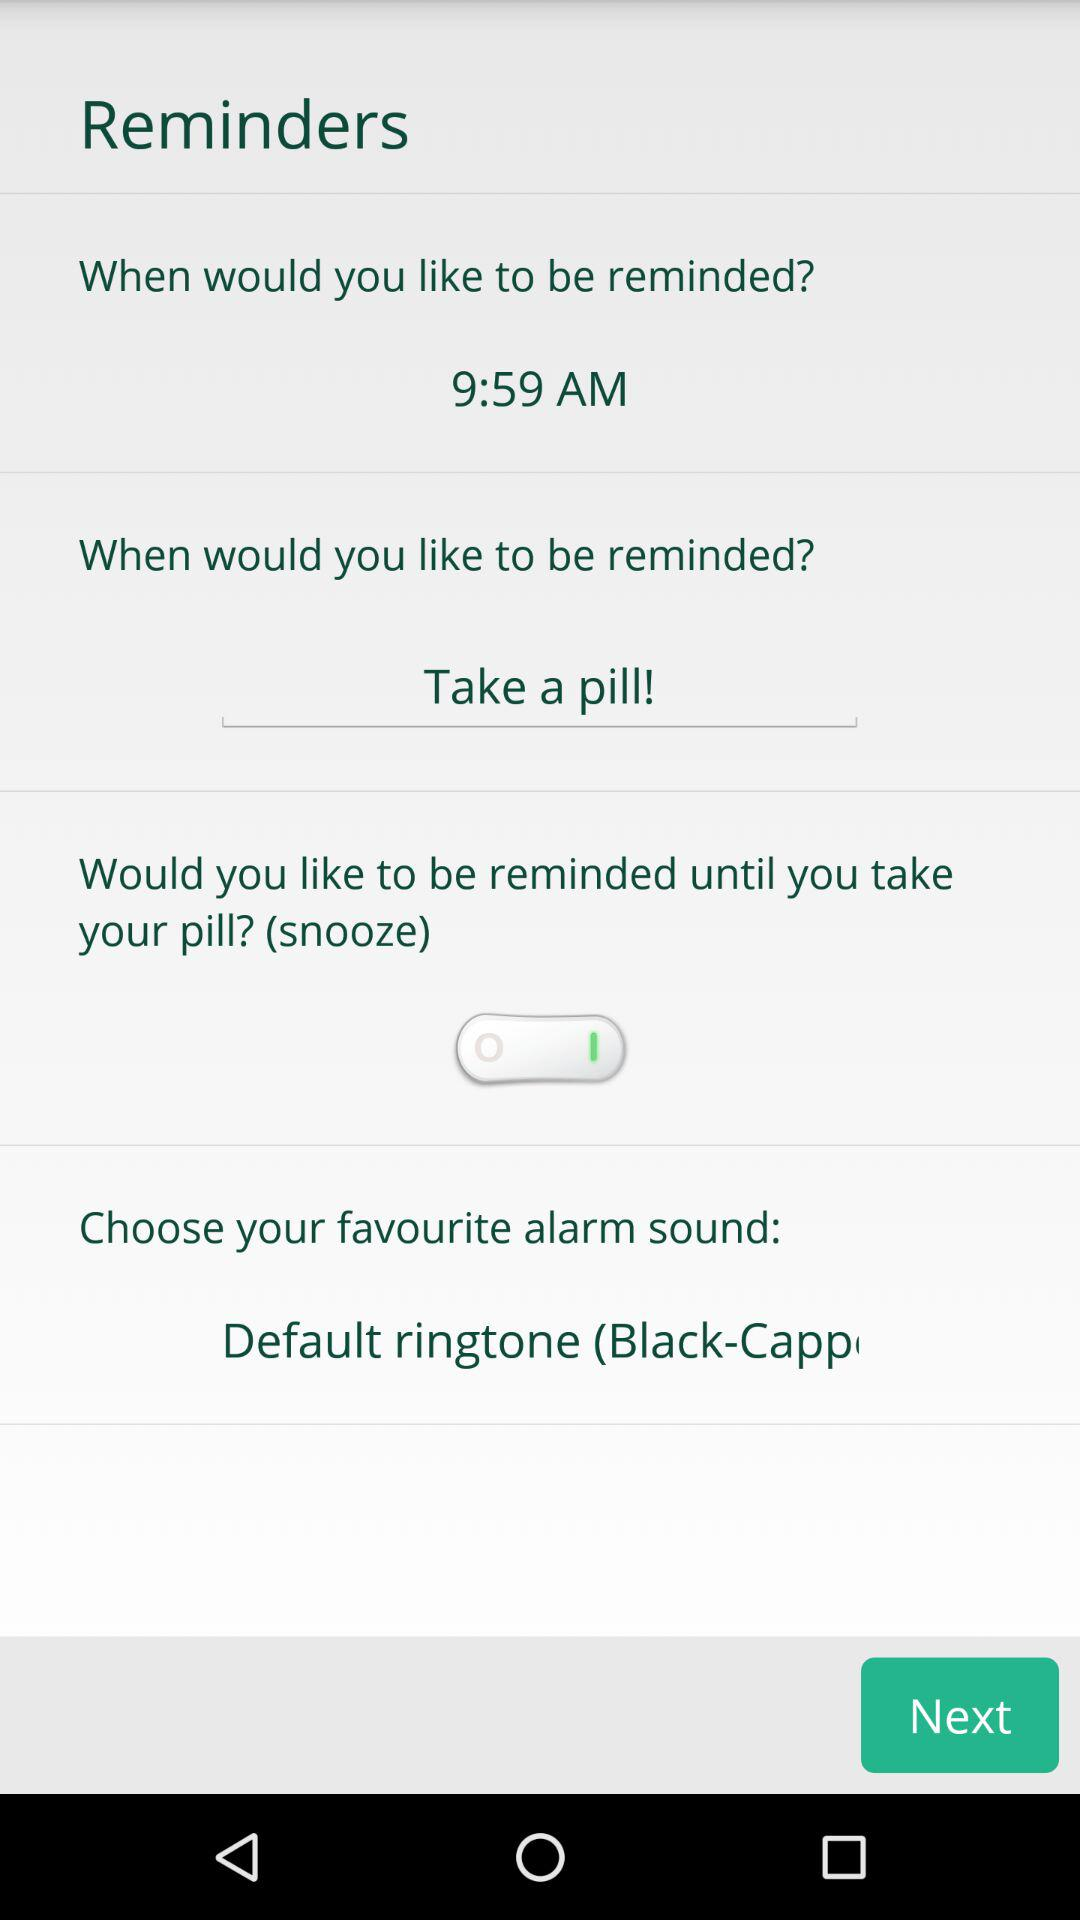For what should I get reminded? You should get reminded to take a pill. 